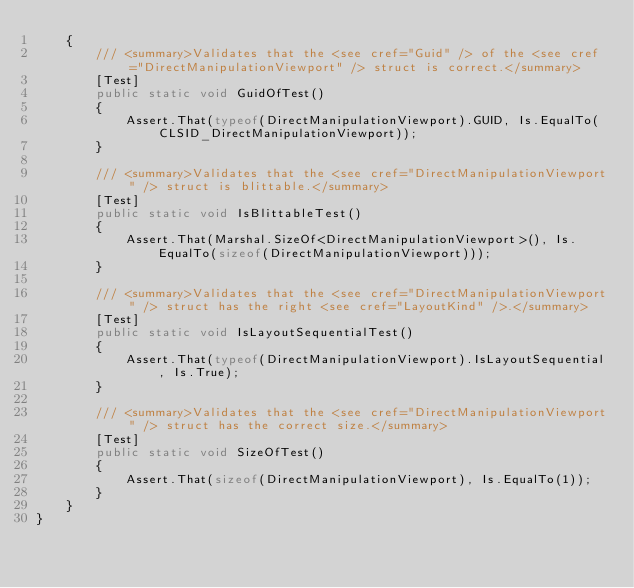<code> <loc_0><loc_0><loc_500><loc_500><_C#_>    {
        /// <summary>Validates that the <see cref="Guid" /> of the <see cref="DirectManipulationViewport" /> struct is correct.</summary>
        [Test]
        public static void GuidOfTest()
        {
            Assert.That(typeof(DirectManipulationViewport).GUID, Is.EqualTo(CLSID_DirectManipulationViewport));
        }

        /// <summary>Validates that the <see cref="DirectManipulationViewport" /> struct is blittable.</summary>
        [Test]
        public static void IsBlittableTest()
        {
            Assert.That(Marshal.SizeOf<DirectManipulationViewport>(), Is.EqualTo(sizeof(DirectManipulationViewport)));
        }

        /// <summary>Validates that the <see cref="DirectManipulationViewport" /> struct has the right <see cref="LayoutKind" />.</summary>
        [Test]
        public static void IsLayoutSequentialTest()
        {
            Assert.That(typeof(DirectManipulationViewport).IsLayoutSequential, Is.True);
        }

        /// <summary>Validates that the <see cref="DirectManipulationViewport" /> struct has the correct size.</summary>
        [Test]
        public static void SizeOfTest()
        {
            Assert.That(sizeof(DirectManipulationViewport), Is.EqualTo(1));
        }
    }
}
</code> 